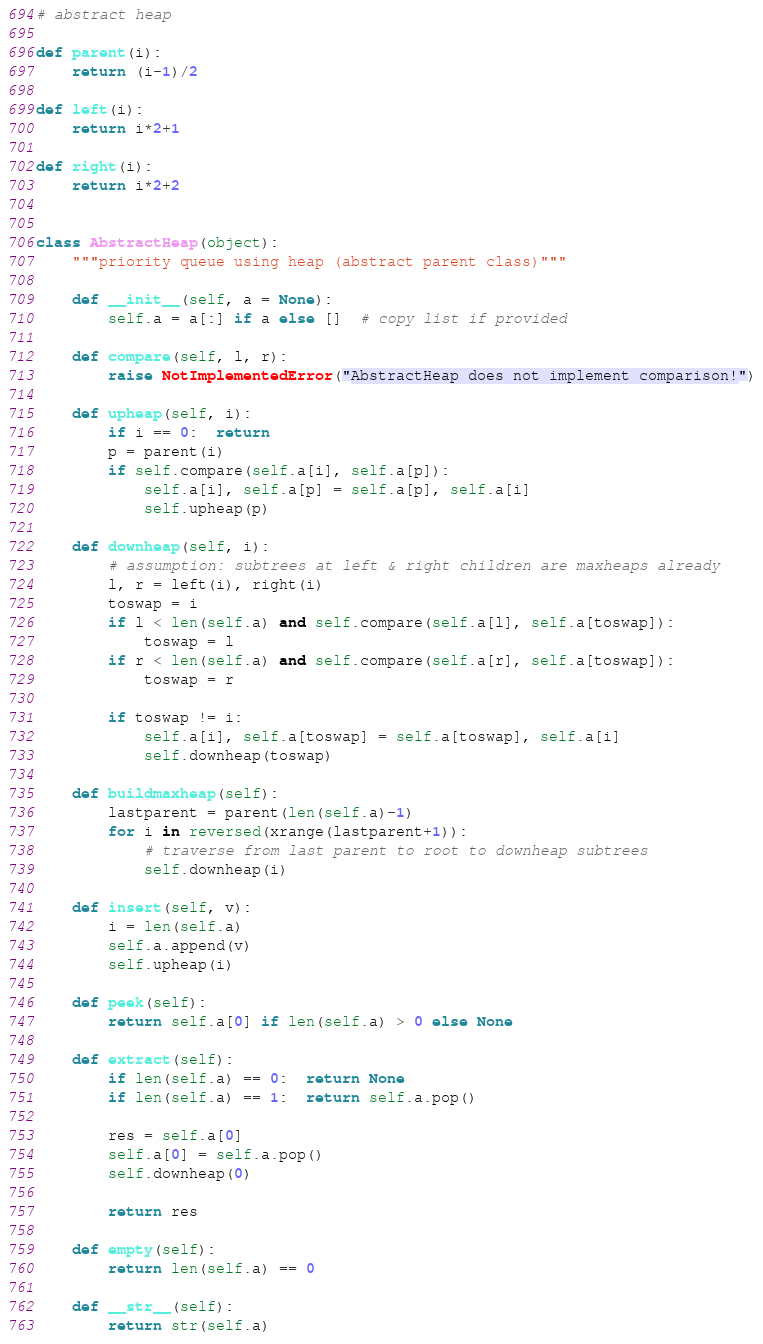<code> <loc_0><loc_0><loc_500><loc_500><_Python_># abstract heap

def parent(i):
    return (i-1)/2

def left(i):
    return i*2+1

def right(i):
    return i*2+2


class AbstractHeap(object):
    """priority queue using heap (abstract parent class)"""

    def __init__(self, a = None):
        self.a = a[:] if a else []  # copy list if provided

    def compare(self, l, r):
        raise NotImplementedError("AbstractHeap does not implement comparison!")

    def upheap(self, i):
        if i == 0:  return
        p = parent(i)
        if self.compare(self.a[i], self.a[p]):
            self.a[i], self.a[p] = self.a[p], self.a[i]
            self.upheap(p)

    def downheap(self, i):
        # assumption: subtrees at left & right children are maxheaps already
        l, r = left(i), right(i)
        toswap = i
        if l < len(self.a) and self.compare(self.a[l], self.a[toswap]):
            toswap = l
        if r < len(self.a) and self.compare(self.a[r], self.a[toswap]):
            toswap = r

        if toswap != i:
            self.a[i], self.a[toswap] = self.a[toswap], self.a[i]
            self.downheap(toswap)

    def buildmaxheap(self):
        lastparent = parent(len(self.a)-1)
        for i in reversed(xrange(lastparent+1)):
            # traverse from last parent to root to downheap subtrees
            self.downheap(i)

    def insert(self, v):
        i = len(self.a)
        self.a.append(v)
        self.upheap(i)

    def peek(self):
        return self.a[0] if len(self.a) > 0 else None

    def extract(self):
        if len(self.a) == 0:  return None
        if len(self.a) == 1:  return self.a.pop()

        res = self.a[0]
        self.a[0] = self.a.pop()
        self.downheap(0)

        return res

    def empty(self):
        return len(self.a) == 0

    def __str__(self):
        return str(self.a)
</code> 